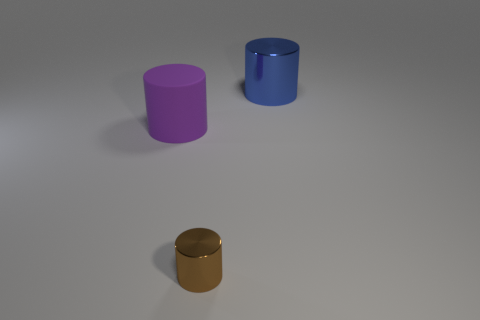Are there an equal number of small brown cylinders to the left of the purple rubber thing and purple cylinders?
Offer a terse response. No. Does the purple thing have the same size as the blue shiny cylinder?
Make the answer very short. Yes. Is there a brown object that is to the right of the metallic cylinder right of the metallic cylinder that is in front of the blue cylinder?
Provide a short and direct response. No. What material is the brown object that is the same shape as the big purple matte object?
Your response must be concise. Metal. There is a purple cylinder left of the tiny brown metal thing; what number of large purple things are on the right side of it?
Your answer should be very brief. 0. There is a cylinder that is on the left side of the metal thing in front of the shiny cylinder behind the purple cylinder; what is its size?
Your answer should be very brief. Large. There is a thing in front of the big cylinder to the left of the brown object; what color is it?
Your response must be concise. Brown. How many other things are there of the same material as the large blue object?
Provide a succinct answer. 1. How many other objects are there of the same color as the matte object?
Give a very brief answer. 0. There is a big thing behind the big cylinder that is in front of the blue metallic cylinder; what is its material?
Your response must be concise. Metal. 